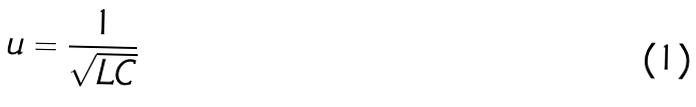Convert formula to latex. <formula><loc_0><loc_0><loc_500><loc_500>u = \frac { 1 } { \sqrt { L C } }</formula> 